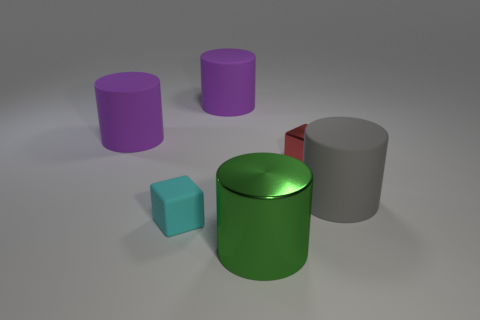There is a large object that is right of the large metal thing; what number of gray rubber things are on the right side of it?
Provide a short and direct response. 0. What shape is the large object that is on the left side of the small metal cube and in front of the shiny block?
Offer a terse response. Cylinder. Is there a big metallic cylinder on the left side of the small cube right of the large cylinder in front of the small cyan matte block?
Ensure brevity in your answer.  Yes. What size is the matte cylinder that is on the left side of the green shiny cylinder and to the right of the matte cube?
Make the answer very short. Large. What number of big green objects have the same material as the tiny red block?
Make the answer very short. 1. How many cylinders are either purple objects or large metal objects?
Your response must be concise. 3. How big is the purple object behind the purple cylinder that is to the left of the cube in front of the small red metal block?
Make the answer very short. Large. What is the color of the matte thing that is to the right of the small cyan block and on the left side of the green cylinder?
Keep it short and to the point. Purple. There is a gray rubber cylinder; is it the same size as the metallic thing to the left of the small red metallic block?
Provide a short and direct response. Yes. Is there any other thing that has the same shape as the tiny red thing?
Make the answer very short. Yes. 